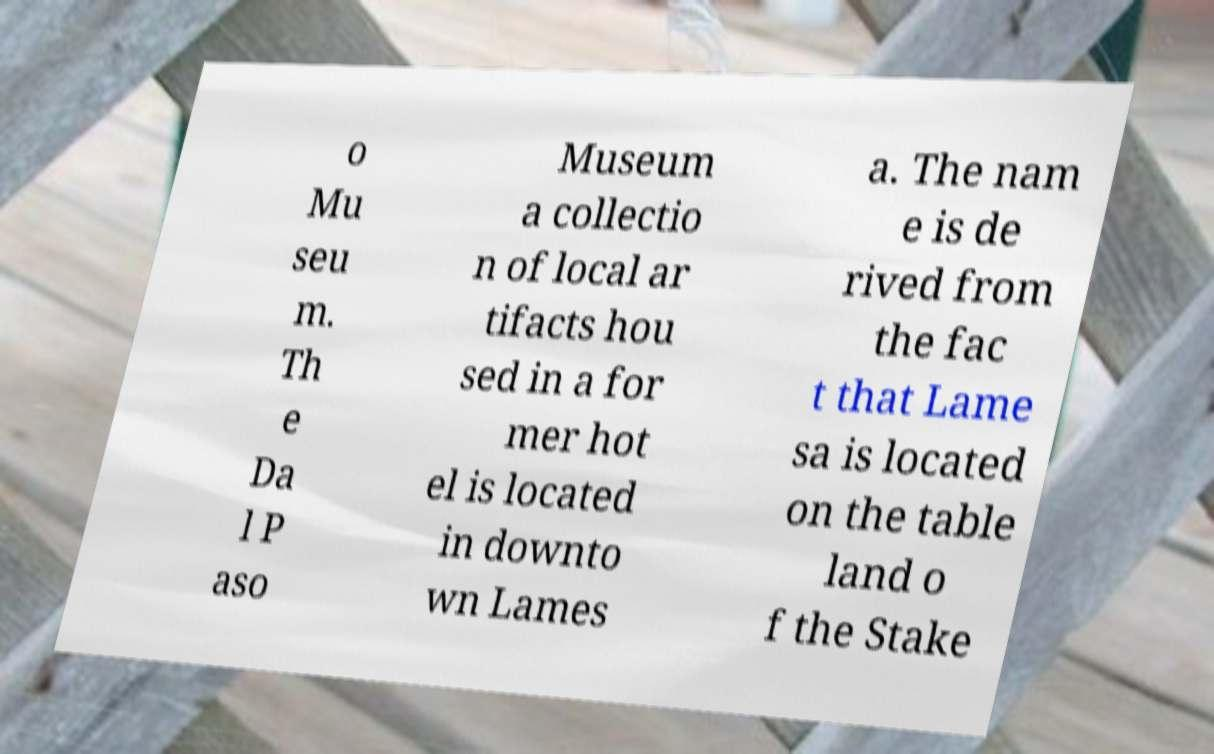For documentation purposes, I need the text within this image transcribed. Could you provide that? o Mu seu m. Th e Da l P aso Museum a collectio n of local ar tifacts hou sed in a for mer hot el is located in downto wn Lames a. The nam e is de rived from the fac t that Lame sa is located on the table land o f the Stake 